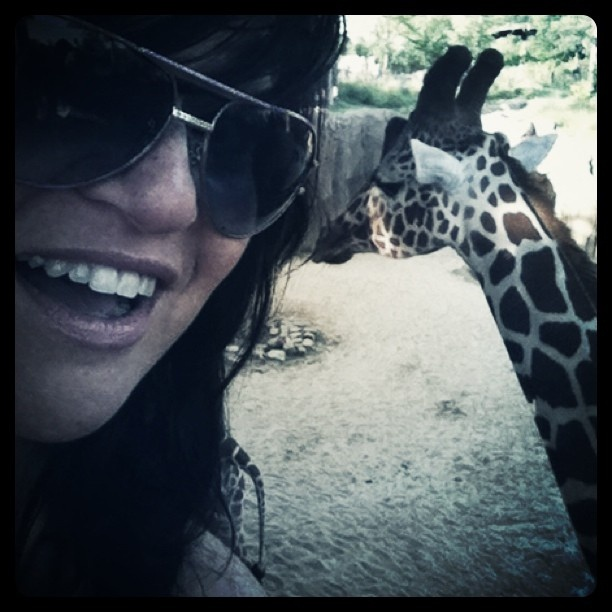Describe the objects in this image and their specific colors. I can see people in black, gray, and darkgray tones and giraffe in black, gray, darkgray, and darkblue tones in this image. 